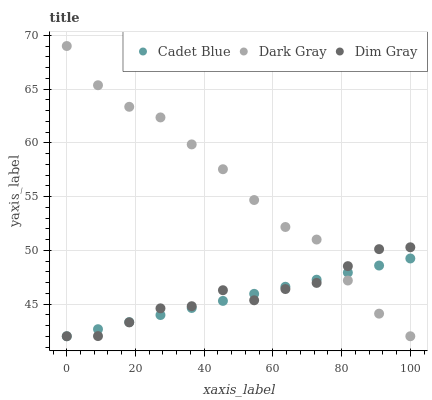Does Cadet Blue have the minimum area under the curve?
Answer yes or no. Yes. Does Dark Gray have the maximum area under the curve?
Answer yes or no. Yes. Does Dim Gray have the minimum area under the curve?
Answer yes or no. No. Does Dim Gray have the maximum area under the curve?
Answer yes or no. No. Is Cadet Blue the smoothest?
Answer yes or no. Yes. Is Dark Gray the roughest?
Answer yes or no. Yes. Is Dim Gray the smoothest?
Answer yes or no. No. Is Dim Gray the roughest?
Answer yes or no. No. Does Dark Gray have the lowest value?
Answer yes or no. Yes. Does Dark Gray have the highest value?
Answer yes or no. Yes. Does Dim Gray have the highest value?
Answer yes or no. No. Does Cadet Blue intersect Dark Gray?
Answer yes or no. Yes. Is Cadet Blue less than Dark Gray?
Answer yes or no. No. Is Cadet Blue greater than Dark Gray?
Answer yes or no. No. 